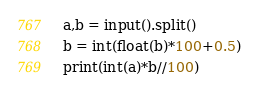Convert code to text. <code><loc_0><loc_0><loc_500><loc_500><_Python_>a,b = input().split()
b = int(float(b)*100+0.5)
print(int(a)*b//100)</code> 